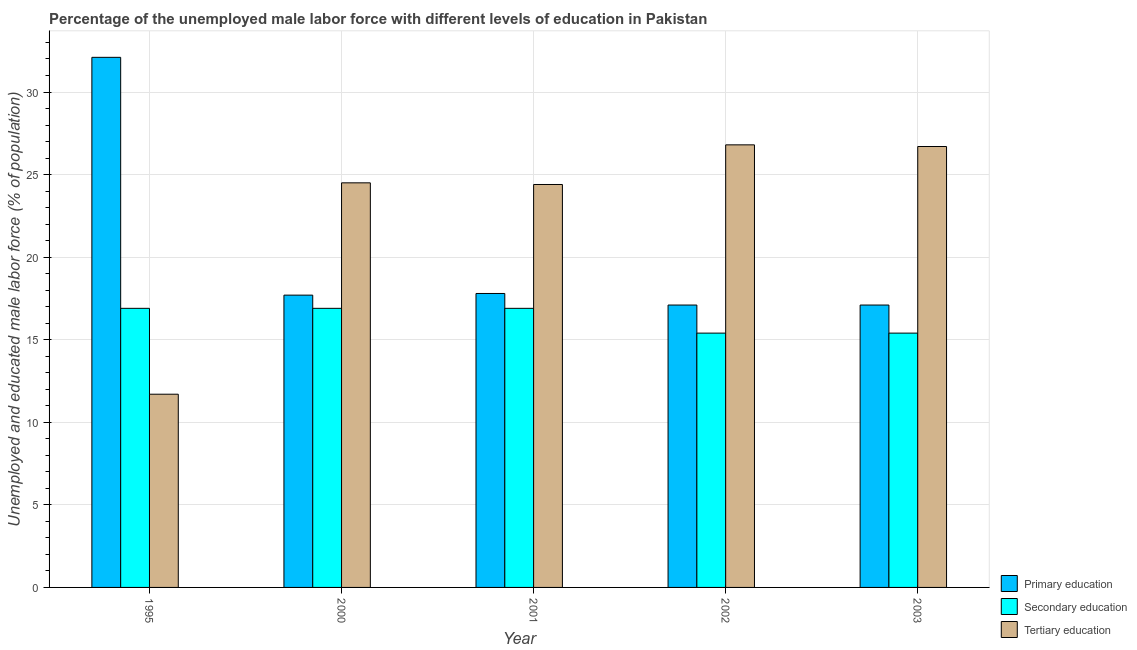How many bars are there on the 4th tick from the left?
Offer a terse response. 3. What is the label of the 5th group of bars from the left?
Offer a very short reply. 2003. What is the percentage of male labor force who received primary education in 2000?
Offer a terse response. 17.7. Across all years, what is the maximum percentage of male labor force who received secondary education?
Offer a very short reply. 16.9. Across all years, what is the minimum percentage of male labor force who received tertiary education?
Your answer should be compact. 11.7. In which year was the percentage of male labor force who received tertiary education maximum?
Give a very brief answer. 2002. In which year was the percentage of male labor force who received primary education minimum?
Your response must be concise. 2002. What is the total percentage of male labor force who received tertiary education in the graph?
Ensure brevity in your answer.  114.1. What is the difference between the percentage of male labor force who received secondary education in 2003 and the percentage of male labor force who received tertiary education in 2001?
Make the answer very short. -1.5. What is the average percentage of male labor force who received tertiary education per year?
Provide a succinct answer. 22.82. In how many years, is the percentage of male labor force who received secondary education greater than 26 %?
Your response must be concise. 0. What is the ratio of the percentage of male labor force who received primary education in 1995 to that in 2003?
Your answer should be compact. 1.88. Is the percentage of male labor force who received tertiary education in 2002 less than that in 2003?
Offer a terse response. No. Is the difference between the percentage of male labor force who received tertiary education in 2000 and 2003 greater than the difference between the percentage of male labor force who received secondary education in 2000 and 2003?
Provide a succinct answer. No. What is the difference between the highest and the second highest percentage of male labor force who received primary education?
Provide a succinct answer. 14.3. What is the difference between the highest and the lowest percentage of male labor force who received primary education?
Make the answer very short. 15. What does the 3rd bar from the left in 2000 represents?
Your answer should be compact. Tertiary education. What does the 1st bar from the right in 2001 represents?
Provide a short and direct response. Tertiary education. Are all the bars in the graph horizontal?
Your answer should be compact. No. How many years are there in the graph?
Provide a succinct answer. 5. What is the difference between two consecutive major ticks on the Y-axis?
Ensure brevity in your answer.  5. Does the graph contain grids?
Your answer should be compact. Yes. How are the legend labels stacked?
Your answer should be compact. Vertical. What is the title of the graph?
Your answer should be compact. Percentage of the unemployed male labor force with different levels of education in Pakistan. What is the label or title of the X-axis?
Provide a short and direct response. Year. What is the label or title of the Y-axis?
Provide a short and direct response. Unemployed and educated male labor force (% of population). What is the Unemployed and educated male labor force (% of population) in Primary education in 1995?
Your answer should be compact. 32.1. What is the Unemployed and educated male labor force (% of population) of Secondary education in 1995?
Provide a short and direct response. 16.9. What is the Unemployed and educated male labor force (% of population) in Tertiary education in 1995?
Ensure brevity in your answer.  11.7. What is the Unemployed and educated male labor force (% of population) of Primary education in 2000?
Your answer should be compact. 17.7. What is the Unemployed and educated male labor force (% of population) of Secondary education in 2000?
Your response must be concise. 16.9. What is the Unemployed and educated male labor force (% of population) of Tertiary education in 2000?
Keep it short and to the point. 24.5. What is the Unemployed and educated male labor force (% of population) in Primary education in 2001?
Ensure brevity in your answer.  17.8. What is the Unemployed and educated male labor force (% of population) in Secondary education in 2001?
Your answer should be compact. 16.9. What is the Unemployed and educated male labor force (% of population) in Tertiary education in 2001?
Your answer should be very brief. 24.4. What is the Unemployed and educated male labor force (% of population) in Primary education in 2002?
Offer a terse response. 17.1. What is the Unemployed and educated male labor force (% of population) of Secondary education in 2002?
Provide a succinct answer. 15.4. What is the Unemployed and educated male labor force (% of population) of Tertiary education in 2002?
Make the answer very short. 26.8. What is the Unemployed and educated male labor force (% of population) in Primary education in 2003?
Keep it short and to the point. 17.1. What is the Unemployed and educated male labor force (% of population) in Secondary education in 2003?
Provide a short and direct response. 15.4. What is the Unemployed and educated male labor force (% of population) in Tertiary education in 2003?
Give a very brief answer. 26.7. Across all years, what is the maximum Unemployed and educated male labor force (% of population) in Primary education?
Give a very brief answer. 32.1. Across all years, what is the maximum Unemployed and educated male labor force (% of population) of Secondary education?
Your response must be concise. 16.9. Across all years, what is the maximum Unemployed and educated male labor force (% of population) in Tertiary education?
Your answer should be compact. 26.8. Across all years, what is the minimum Unemployed and educated male labor force (% of population) in Primary education?
Offer a very short reply. 17.1. Across all years, what is the minimum Unemployed and educated male labor force (% of population) in Secondary education?
Your answer should be very brief. 15.4. Across all years, what is the minimum Unemployed and educated male labor force (% of population) of Tertiary education?
Your response must be concise. 11.7. What is the total Unemployed and educated male labor force (% of population) of Primary education in the graph?
Provide a short and direct response. 101.8. What is the total Unemployed and educated male labor force (% of population) of Secondary education in the graph?
Offer a terse response. 81.5. What is the total Unemployed and educated male labor force (% of population) of Tertiary education in the graph?
Offer a terse response. 114.1. What is the difference between the Unemployed and educated male labor force (% of population) in Primary education in 1995 and that in 2000?
Offer a terse response. 14.4. What is the difference between the Unemployed and educated male labor force (% of population) of Tertiary education in 1995 and that in 2000?
Your response must be concise. -12.8. What is the difference between the Unemployed and educated male labor force (% of population) in Secondary education in 1995 and that in 2001?
Offer a very short reply. 0. What is the difference between the Unemployed and educated male labor force (% of population) in Tertiary education in 1995 and that in 2001?
Provide a short and direct response. -12.7. What is the difference between the Unemployed and educated male labor force (% of population) of Primary education in 1995 and that in 2002?
Your answer should be very brief. 15. What is the difference between the Unemployed and educated male labor force (% of population) in Tertiary education in 1995 and that in 2002?
Keep it short and to the point. -15.1. What is the difference between the Unemployed and educated male labor force (% of population) in Primary education in 2000 and that in 2001?
Keep it short and to the point. -0.1. What is the difference between the Unemployed and educated male labor force (% of population) of Primary education in 2000 and that in 2002?
Provide a succinct answer. 0.6. What is the difference between the Unemployed and educated male labor force (% of population) of Secondary education in 2000 and that in 2002?
Offer a very short reply. 1.5. What is the difference between the Unemployed and educated male labor force (% of population) in Tertiary education in 2000 and that in 2002?
Your answer should be compact. -2.3. What is the difference between the Unemployed and educated male labor force (% of population) of Primary education in 2000 and that in 2003?
Offer a terse response. 0.6. What is the difference between the Unemployed and educated male labor force (% of population) of Tertiary education in 2000 and that in 2003?
Offer a very short reply. -2.2. What is the difference between the Unemployed and educated male labor force (% of population) in Primary education in 2001 and that in 2002?
Provide a short and direct response. 0.7. What is the difference between the Unemployed and educated male labor force (% of population) in Secondary education in 2001 and that in 2002?
Your answer should be compact. 1.5. What is the difference between the Unemployed and educated male labor force (% of population) of Tertiary education in 2001 and that in 2002?
Give a very brief answer. -2.4. What is the difference between the Unemployed and educated male labor force (% of population) of Secondary education in 2001 and that in 2003?
Ensure brevity in your answer.  1.5. What is the difference between the Unemployed and educated male labor force (% of population) in Tertiary education in 2001 and that in 2003?
Provide a succinct answer. -2.3. What is the difference between the Unemployed and educated male labor force (% of population) in Tertiary education in 2002 and that in 2003?
Your answer should be very brief. 0.1. What is the difference between the Unemployed and educated male labor force (% of population) of Primary education in 1995 and the Unemployed and educated male labor force (% of population) of Secondary education in 2000?
Provide a short and direct response. 15.2. What is the difference between the Unemployed and educated male labor force (% of population) of Primary education in 1995 and the Unemployed and educated male labor force (% of population) of Tertiary education in 2000?
Provide a short and direct response. 7.6. What is the difference between the Unemployed and educated male labor force (% of population) in Secondary education in 1995 and the Unemployed and educated male labor force (% of population) in Tertiary education in 2000?
Make the answer very short. -7.6. What is the difference between the Unemployed and educated male labor force (% of population) in Primary education in 1995 and the Unemployed and educated male labor force (% of population) in Secondary education in 2001?
Ensure brevity in your answer.  15.2. What is the difference between the Unemployed and educated male labor force (% of population) of Primary education in 1995 and the Unemployed and educated male labor force (% of population) of Tertiary education in 2001?
Provide a short and direct response. 7.7. What is the difference between the Unemployed and educated male labor force (% of population) in Primary education in 1995 and the Unemployed and educated male labor force (% of population) in Secondary education in 2003?
Provide a short and direct response. 16.7. What is the difference between the Unemployed and educated male labor force (% of population) in Primary education in 2000 and the Unemployed and educated male labor force (% of population) in Secondary education in 2001?
Your response must be concise. 0.8. What is the difference between the Unemployed and educated male labor force (% of population) of Primary education in 2000 and the Unemployed and educated male labor force (% of population) of Secondary education in 2002?
Give a very brief answer. 2.3. What is the difference between the Unemployed and educated male labor force (% of population) in Secondary education in 2000 and the Unemployed and educated male labor force (% of population) in Tertiary education in 2002?
Ensure brevity in your answer.  -9.9. What is the difference between the Unemployed and educated male labor force (% of population) of Primary education in 2000 and the Unemployed and educated male labor force (% of population) of Secondary education in 2003?
Your answer should be compact. 2.3. What is the difference between the Unemployed and educated male labor force (% of population) in Primary education in 2000 and the Unemployed and educated male labor force (% of population) in Tertiary education in 2003?
Your answer should be compact. -9. What is the difference between the Unemployed and educated male labor force (% of population) in Secondary education in 2000 and the Unemployed and educated male labor force (% of population) in Tertiary education in 2003?
Ensure brevity in your answer.  -9.8. What is the difference between the Unemployed and educated male labor force (% of population) of Primary education in 2001 and the Unemployed and educated male labor force (% of population) of Secondary education in 2002?
Your response must be concise. 2.4. What is the difference between the Unemployed and educated male labor force (% of population) in Secondary education in 2001 and the Unemployed and educated male labor force (% of population) in Tertiary education in 2002?
Offer a very short reply. -9.9. What is the difference between the Unemployed and educated male labor force (% of population) in Primary education in 2001 and the Unemployed and educated male labor force (% of population) in Tertiary education in 2003?
Offer a very short reply. -8.9. What is the difference between the Unemployed and educated male labor force (% of population) of Secondary education in 2001 and the Unemployed and educated male labor force (% of population) of Tertiary education in 2003?
Offer a very short reply. -9.8. What is the difference between the Unemployed and educated male labor force (% of population) of Primary education in 2002 and the Unemployed and educated male labor force (% of population) of Secondary education in 2003?
Offer a terse response. 1.7. What is the difference between the Unemployed and educated male labor force (% of population) in Primary education in 2002 and the Unemployed and educated male labor force (% of population) in Tertiary education in 2003?
Provide a short and direct response. -9.6. What is the difference between the Unemployed and educated male labor force (% of population) in Secondary education in 2002 and the Unemployed and educated male labor force (% of population) in Tertiary education in 2003?
Make the answer very short. -11.3. What is the average Unemployed and educated male labor force (% of population) of Primary education per year?
Give a very brief answer. 20.36. What is the average Unemployed and educated male labor force (% of population) of Tertiary education per year?
Make the answer very short. 22.82. In the year 1995, what is the difference between the Unemployed and educated male labor force (% of population) of Primary education and Unemployed and educated male labor force (% of population) of Tertiary education?
Your answer should be compact. 20.4. In the year 1995, what is the difference between the Unemployed and educated male labor force (% of population) in Secondary education and Unemployed and educated male labor force (% of population) in Tertiary education?
Your answer should be very brief. 5.2. In the year 2000, what is the difference between the Unemployed and educated male labor force (% of population) of Secondary education and Unemployed and educated male labor force (% of population) of Tertiary education?
Your response must be concise. -7.6. In the year 2001, what is the difference between the Unemployed and educated male labor force (% of population) in Primary education and Unemployed and educated male labor force (% of population) in Tertiary education?
Your answer should be compact. -6.6. In the year 2002, what is the difference between the Unemployed and educated male labor force (% of population) in Primary education and Unemployed and educated male labor force (% of population) in Secondary education?
Your answer should be very brief. 1.7. In the year 2003, what is the difference between the Unemployed and educated male labor force (% of population) in Secondary education and Unemployed and educated male labor force (% of population) in Tertiary education?
Provide a succinct answer. -11.3. What is the ratio of the Unemployed and educated male labor force (% of population) in Primary education in 1995 to that in 2000?
Make the answer very short. 1.81. What is the ratio of the Unemployed and educated male labor force (% of population) in Tertiary education in 1995 to that in 2000?
Keep it short and to the point. 0.48. What is the ratio of the Unemployed and educated male labor force (% of population) in Primary education in 1995 to that in 2001?
Keep it short and to the point. 1.8. What is the ratio of the Unemployed and educated male labor force (% of population) of Tertiary education in 1995 to that in 2001?
Ensure brevity in your answer.  0.48. What is the ratio of the Unemployed and educated male labor force (% of population) in Primary education in 1995 to that in 2002?
Make the answer very short. 1.88. What is the ratio of the Unemployed and educated male labor force (% of population) of Secondary education in 1995 to that in 2002?
Give a very brief answer. 1.1. What is the ratio of the Unemployed and educated male labor force (% of population) of Tertiary education in 1995 to that in 2002?
Keep it short and to the point. 0.44. What is the ratio of the Unemployed and educated male labor force (% of population) of Primary education in 1995 to that in 2003?
Offer a very short reply. 1.88. What is the ratio of the Unemployed and educated male labor force (% of population) of Secondary education in 1995 to that in 2003?
Ensure brevity in your answer.  1.1. What is the ratio of the Unemployed and educated male labor force (% of population) of Tertiary education in 1995 to that in 2003?
Keep it short and to the point. 0.44. What is the ratio of the Unemployed and educated male labor force (% of population) in Primary education in 2000 to that in 2001?
Ensure brevity in your answer.  0.99. What is the ratio of the Unemployed and educated male labor force (% of population) in Secondary education in 2000 to that in 2001?
Keep it short and to the point. 1. What is the ratio of the Unemployed and educated male labor force (% of population) in Tertiary education in 2000 to that in 2001?
Your answer should be very brief. 1. What is the ratio of the Unemployed and educated male labor force (% of population) in Primary education in 2000 to that in 2002?
Offer a very short reply. 1.04. What is the ratio of the Unemployed and educated male labor force (% of population) of Secondary education in 2000 to that in 2002?
Offer a very short reply. 1.1. What is the ratio of the Unemployed and educated male labor force (% of population) in Tertiary education in 2000 to that in 2002?
Ensure brevity in your answer.  0.91. What is the ratio of the Unemployed and educated male labor force (% of population) of Primary education in 2000 to that in 2003?
Offer a terse response. 1.04. What is the ratio of the Unemployed and educated male labor force (% of population) of Secondary education in 2000 to that in 2003?
Provide a succinct answer. 1.1. What is the ratio of the Unemployed and educated male labor force (% of population) of Tertiary education in 2000 to that in 2003?
Keep it short and to the point. 0.92. What is the ratio of the Unemployed and educated male labor force (% of population) in Primary education in 2001 to that in 2002?
Provide a succinct answer. 1.04. What is the ratio of the Unemployed and educated male labor force (% of population) of Secondary education in 2001 to that in 2002?
Your answer should be compact. 1.1. What is the ratio of the Unemployed and educated male labor force (% of population) in Tertiary education in 2001 to that in 2002?
Offer a very short reply. 0.91. What is the ratio of the Unemployed and educated male labor force (% of population) of Primary education in 2001 to that in 2003?
Provide a short and direct response. 1.04. What is the ratio of the Unemployed and educated male labor force (% of population) of Secondary education in 2001 to that in 2003?
Provide a short and direct response. 1.1. What is the ratio of the Unemployed and educated male labor force (% of population) of Tertiary education in 2001 to that in 2003?
Give a very brief answer. 0.91. What is the ratio of the Unemployed and educated male labor force (% of population) of Tertiary education in 2002 to that in 2003?
Your answer should be compact. 1. What is the difference between the highest and the second highest Unemployed and educated male labor force (% of population) of Primary education?
Give a very brief answer. 14.3. 